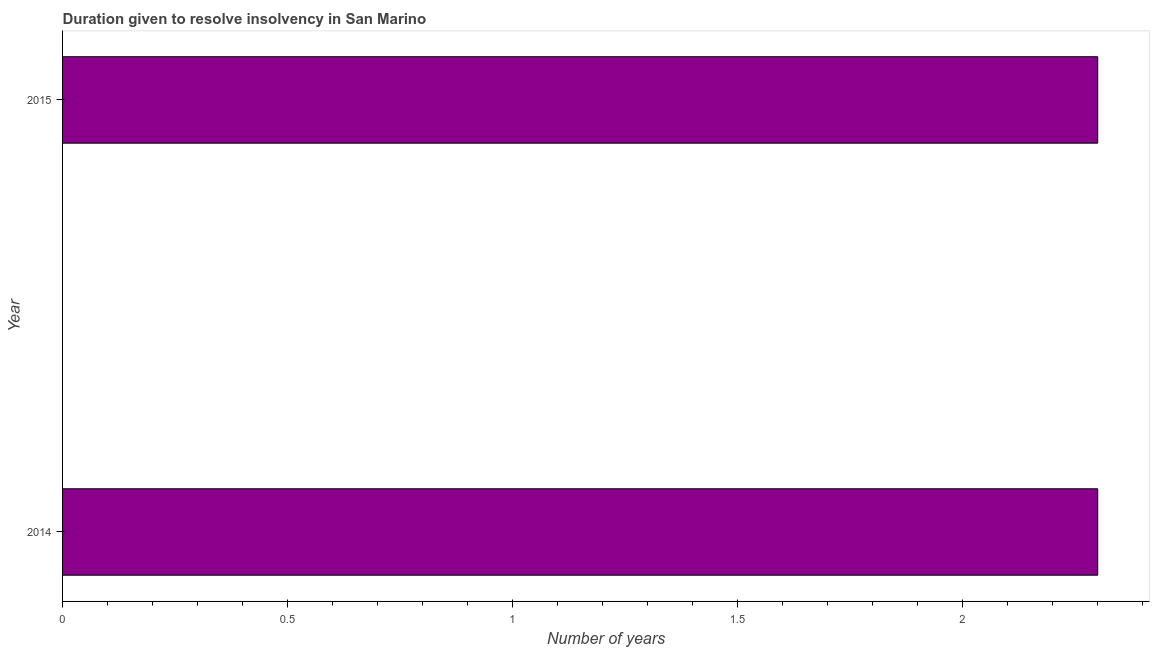Does the graph contain any zero values?
Offer a very short reply. No. What is the title of the graph?
Give a very brief answer. Duration given to resolve insolvency in San Marino. What is the label or title of the X-axis?
Provide a short and direct response. Number of years. Across all years, what is the minimum number of years to resolve insolvency?
Your answer should be very brief. 2.3. In which year was the number of years to resolve insolvency minimum?
Ensure brevity in your answer.  2014. What is the difference between the number of years to resolve insolvency in 2014 and 2015?
Keep it short and to the point. 0. What is the average number of years to resolve insolvency per year?
Your answer should be very brief. 2.3. In how many years, is the number of years to resolve insolvency greater than 0.7 ?
Provide a succinct answer. 2. What is the ratio of the number of years to resolve insolvency in 2014 to that in 2015?
Your response must be concise. 1. Is the number of years to resolve insolvency in 2014 less than that in 2015?
Keep it short and to the point. No. How many bars are there?
Your answer should be compact. 2. Are all the bars in the graph horizontal?
Offer a very short reply. Yes. What is the difference between two consecutive major ticks on the X-axis?
Offer a very short reply. 0.5. Are the values on the major ticks of X-axis written in scientific E-notation?
Ensure brevity in your answer.  No. 